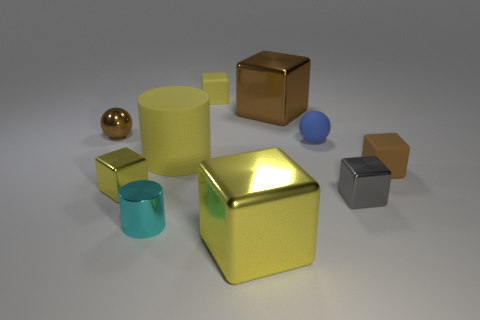Subtract all purple spheres. How many yellow blocks are left? 3 Subtract all tiny yellow blocks. How many blocks are left? 4 Subtract all gray cubes. How many cubes are left? 5 Subtract all red blocks. Subtract all green cylinders. How many blocks are left? 6 Subtract all cubes. How many objects are left? 4 Add 6 cyan cylinders. How many cyan cylinders exist? 7 Subtract 1 cyan cylinders. How many objects are left? 9 Subtract all yellow matte objects. Subtract all tiny purple metallic spheres. How many objects are left? 8 Add 4 tiny gray metallic things. How many tiny gray metallic things are left? 5 